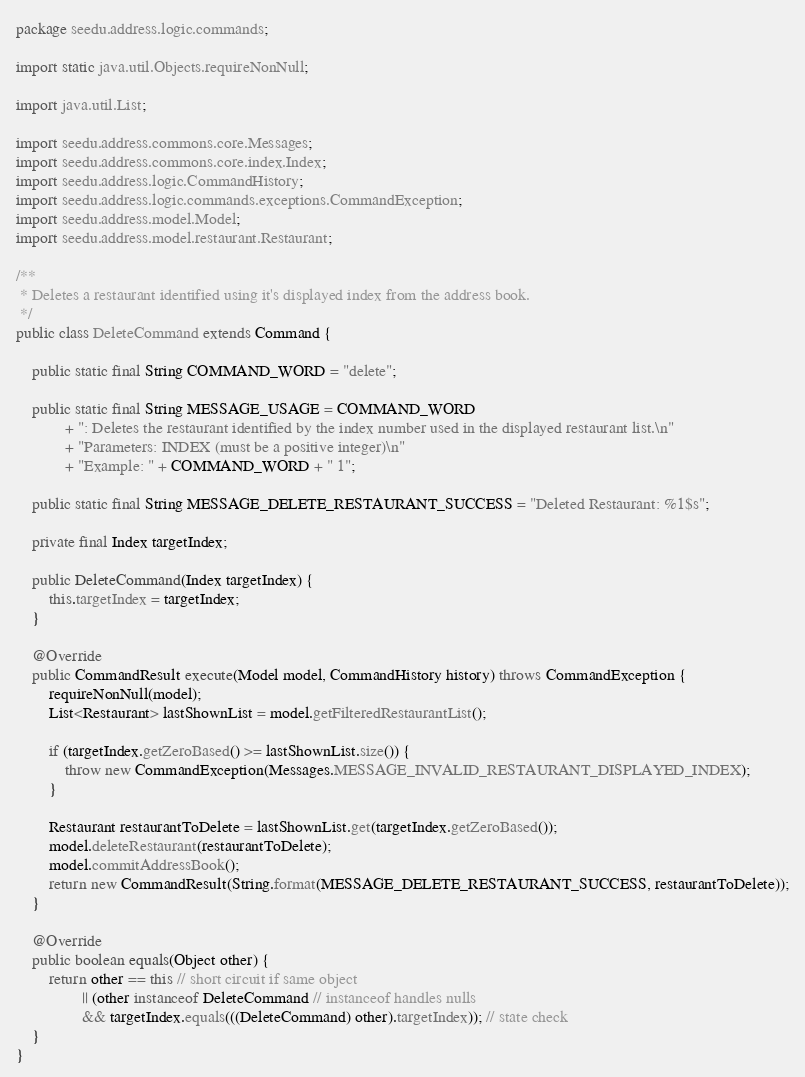<code> <loc_0><loc_0><loc_500><loc_500><_Java_>package seedu.address.logic.commands;

import static java.util.Objects.requireNonNull;

import java.util.List;

import seedu.address.commons.core.Messages;
import seedu.address.commons.core.index.Index;
import seedu.address.logic.CommandHistory;
import seedu.address.logic.commands.exceptions.CommandException;
import seedu.address.model.Model;
import seedu.address.model.restaurant.Restaurant;

/**
 * Deletes a restaurant identified using it's displayed index from the address book.
 */
public class DeleteCommand extends Command {

    public static final String COMMAND_WORD = "delete";

    public static final String MESSAGE_USAGE = COMMAND_WORD
            + ": Deletes the restaurant identified by the index number used in the displayed restaurant list.\n"
            + "Parameters: INDEX (must be a positive integer)\n"
            + "Example: " + COMMAND_WORD + " 1";

    public static final String MESSAGE_DELETE_RESTAURANT_SUCCESS = "Deleted Restaurant: %1$s";

    private final Index targetIndex;

    public DeleteCommand(Index targetIndex) {
        this.targetIndex = targetIndex;
    }

    @Override
    public CommandResult execute(Model model, CommandHistory history) throws CommandException {
        requireNonNull(model);
        List<Restaurant> lastShownList = model.getFilteredRestaurantList();

        if (targetIndex.getZeroBased() >= lastShownList.size()) {
            throw new CommandException(Messages.MESSAGE_INVALID_RESTAURANT_DISPLAYED_INDEX);
        }

        Restaurant restaurantToDelete = lastShownList.get(targetIndex.getZeroBased());
        model.deleteRestaurant(restaurantToDelete);
        model.commitAddressBook();
        return new CommandResult(String.format(MESSAGE_DELETE_RESTAURANT_SUCCESS, restaurantToDelete));
    }

    @Override
    public boolean equals(Object other) {
        return other == this // short circuit if same object
                || (other instanceof DeleteCommand // instanceof handles nulls
                && targetIndex.equals(((DeleteCommand) other).targetIndex)); // state check
    }
}
</code> 